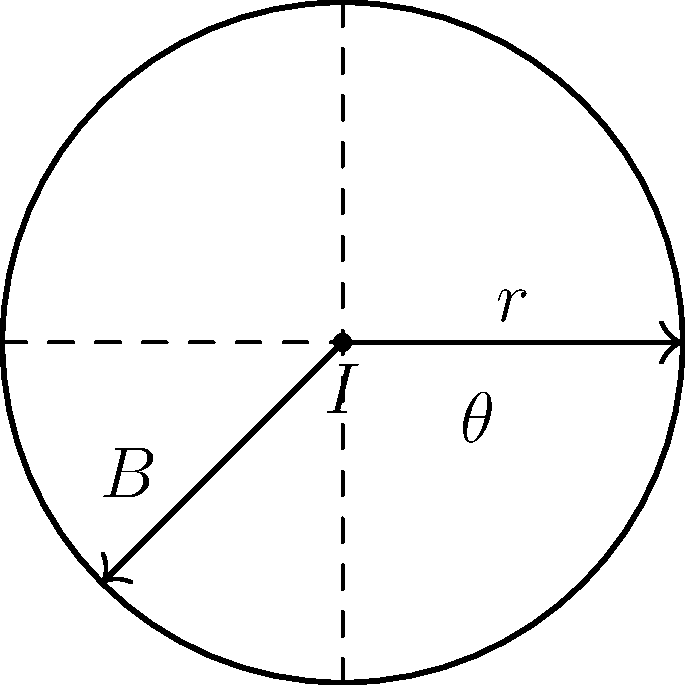As a proud member of Sigma Gamma Rho Sorority, Inc., you're working on an Electrical Engineering project. A straight wire carries a current $I$ of 5 A. At a distance $r$ of 10 cm from the wire, what is the magnitude of the magnetic field $B$ at an angle $\theta$ of 45° from the wire? Use the permeability of free space $\mu_0 = 4\pi \times 10^{-7}$ T⋅m/A. Let's approach this step-by-step:

1) The magnetic field strength $B$ around a straight current-carrying wire is given by the equation:

   $$B = \frac{\mu_0 I}{2\pi r}$$

2) We are given:
   - Current $I = 5$ A
   - Distance $r = 10$ cm $= 0.1$ m
   - Permeability of free space $\mu_0 = 4\pi \times 10^{-7}$ T⋅m/A

3) Let's substitute these values into the equation:

   $$B = \frac{(4\pi \times 10^{-7})(5)}{2\pi(0.1)}$$

4) Simplify:
   
   $$B = \frac{20\pi \times 10^{-7}}{2\pi \times 10^{-1}} = \frac{10 \times 10^{-6}}{10^{-1}} = 10 \times 10^{-5}$$

5) Therefore:

   $$B = 1 \times 10^{-4}$$ T

6) Note that the angle $\theta$ doesn't affect the magnitude of $B$, only its direction. The magnetic field lines form concentric circles around the wire, perpendicular to both the wire and the radial distance from the wire.
Answer: $1 \times 10^{-4}$ T 